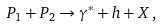Convert formula to latex. <formula><loc_0><loc_0><loc_500><loc_500>P _ { 1 } + P _ { 2 } \rightarrow \gamma ^ { * } + h + X \, ,</formula> 